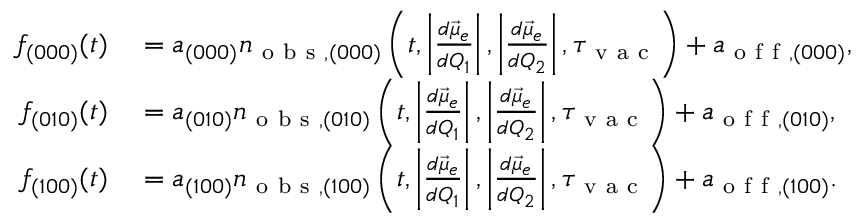<formula> <loc_0><loc_0><loc_500><loc_500>\begin{array} { r l } { f _ { ( 0 0 0 ) } ( t ) } & = a _ { ( 0 0 0 ) } n _ { o b s , ( 0 0 0 ) } \left ( t , \left | \frac { d \vec { \mu } _ { e } } { d Q _ { 1 } } \right | , \left | \frac { d \vec { \mu } _ { e } } { d Q _ { 2 } } \right | , \tau _ { v a c } \right ) + a _ { o f f , ( 0 0 0 ) } , } \\ { f _ { ( 0 1 0 ) } ( t ) } & = a _ { ( 0 1 0 ) } n _ { o b s , ( 0 1 0 ) } \left ( t , \left | \frac { d \vec { \mu } _ { e } } { d Q _ { 1 } } \right | , \left | \frac { d \vec { \mu } _ { e } } { d Q _ { 2 } } \right | , \tau _ { v a c } \right ) + a _ { o f f , ( 0 1 0 ) } , } \\ { f _ { ( 1 0 0 ) } ( t ) } & = a _ { ( 1 0 0 ) } n _ { o b s , ( 1 0 0 ) } \left ( t , \left | \frac { d \vec { \mu } _ { e } } { d Q _ { 1 } } \right | , \left | \frac { d \vec { \mu } _ { e } } { d Q _ { 2 } } \right | , \tau _ { v a c } \right ) + a _ { o f f , ( 1 0 0 ) } . } \end{array}</formula> 